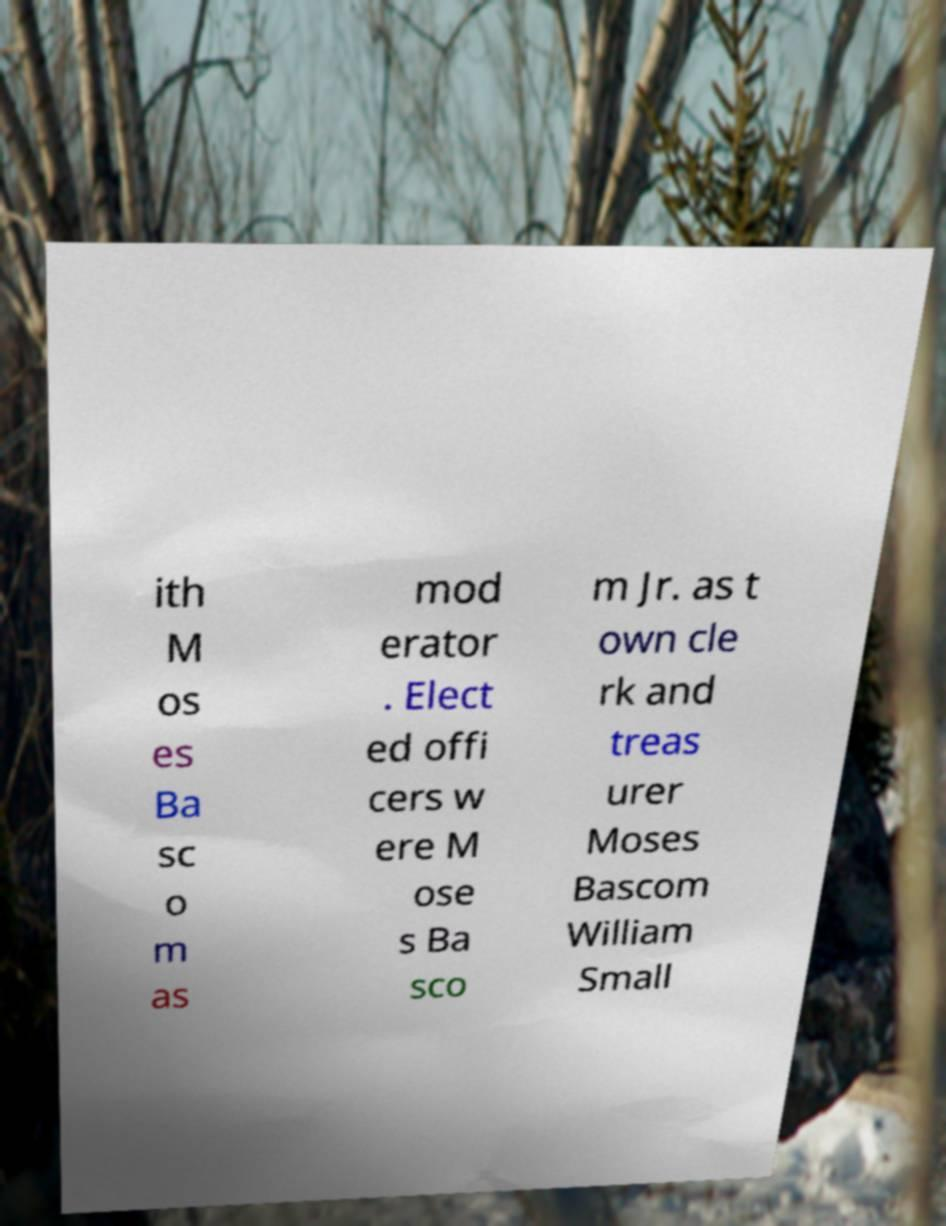For documentation purposes, I need the text within this image transcribed. Could you provide that? ith M os es Ba sc o m as mod erator . Elect ed offi cers w ere M ose s Ba sco m Jr. as t own cle rk and treas urer Moses Bascom William Small 